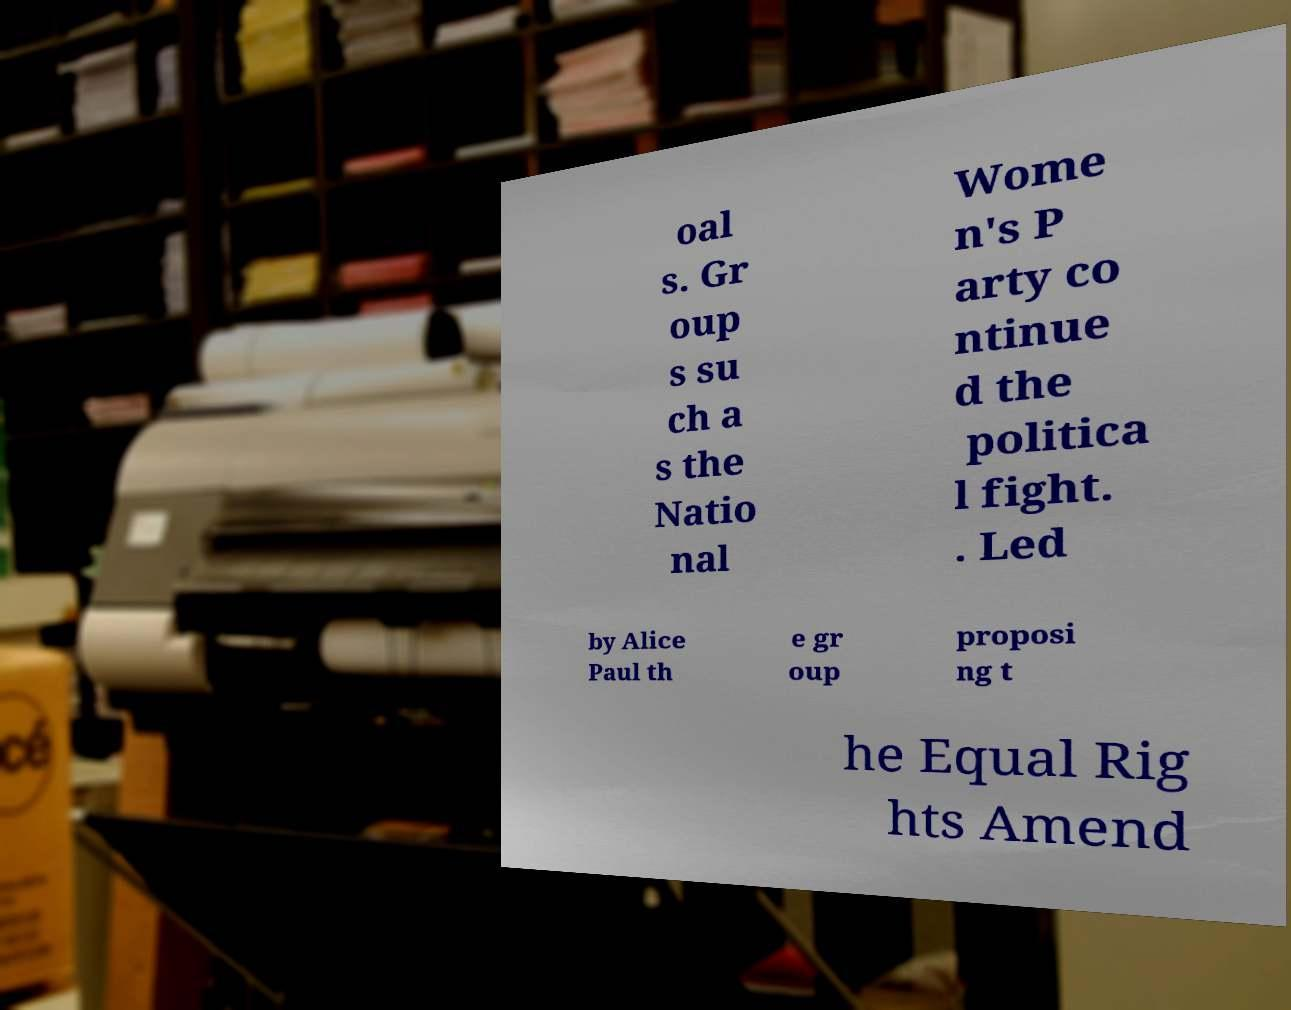I need the written content from this picture converted into text. Can you do that? oal s. Gr oup s su ch a s the Natio nal Wome n's P arty co ntinue d the politica l fight. . Led by Alice Paul th e gr oup proposi ng t he Equal Rig hts Amend 